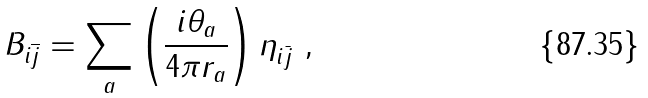<formula> <loc_0><loc_0><loc_500><loc_500>B _ { i \overline { j } } = \sum _ { a } \left ( \frac { i \theta _ { a } } { 4 \pi r _ { a } } \right ) \eta _ { i \bar { j } } \ ,</formula> 